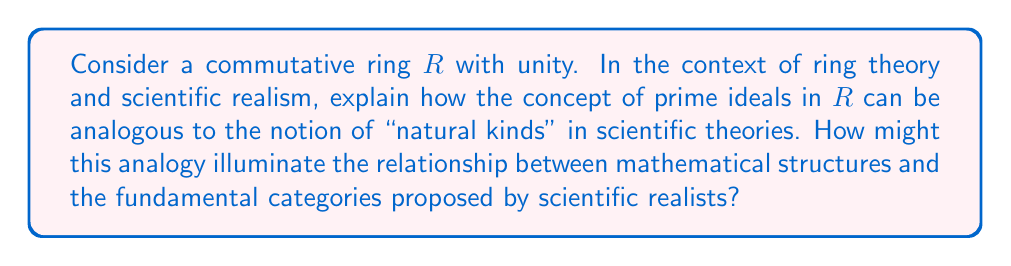Can you answer this question? This question connects ring theory, specifically prime ideals, with concepts in scientific realism. Let's break it down step-by-step:

1. Prime Ideals in Ring Theory:
   A prime ideal $P$ in a commutative ring $R$ is a proper ideal such that for any $a, b \in R$, if $ab \in P$, then either $a \in P$ or $b \in P$. 
   
   Mathematically, $P \neq R$ and $\forall a,b \in R: ab \in P \implies a \in P \text{ or } b \in P$

2. Natural Kinds in Scientific Realism:
   In scientific realism, "natural kinds" refer to categories that exist independently of human classification, representing fundamental divisions in nature (e.g., chemical elements, biological species).

3. Analogy between Prime Ideals and Natural Kinds:
   a) Irreducibility: Prime ideals are "irreducible" in the sense that they cannot be factored into smaller ideals, just as natural kinds are considered fundamental, indivisible categories in nature.
   
   b) Structure-preserving: The quotient ring $R/P$, where $P$ is a prime ideal, is an integral domain. This preservation of algebraic structure is analogous to how natural kinds are thought to preserve essential properties across different contexts.
   
   c) Foundational role: Prime ideals are crucial in understanding the structure of rings, much like how natural kinds are fundamental to scientific theories.

4. Mathematical Structures and Scientific Realism:
   The analogy suggests that mathematical structures (like prime ideals) can model philosophical concepts in scientific realism. This connection implies that:
   
   a) Abstract mathematical concepts can have meaningful correspondences to ideas in the philosophy of science.
   
   b) The rigorous nature of mathematical structures might provide insights into the logical structure of scientific theories.
   
   c) The universality of mathematical concepts could support the idea of mind-independent structures in nature, a key tenet of scientific realism.

5. Limitations of the Analogy:
   It's important to note that while this analogy is illuminating, it has limitations. Mathematical structures are abstract and certain, while scientific theories are empirical and subject to revision.

This analogy provides a framework for understanding how abstract mathematical concepts can relate to philosophical ideas about the nature of scientific knowledge and reality.
Answer: The analogy between prime ideals and natural kinds illuminates the relationship between mathematical structures and fundamental categories in scientific realism by highlighting shared properties of irreducibility, structure preservation, and foundational importance. This suggests that mathematical structures can model and provide insights into philosophical concepts in scientific realism, potentially supporting the idea of mind-independent structures in nature. However, the limitations of this analogy must also be considered, given the differences between abstract mathematical certainty and empirical scientific knowledge. 